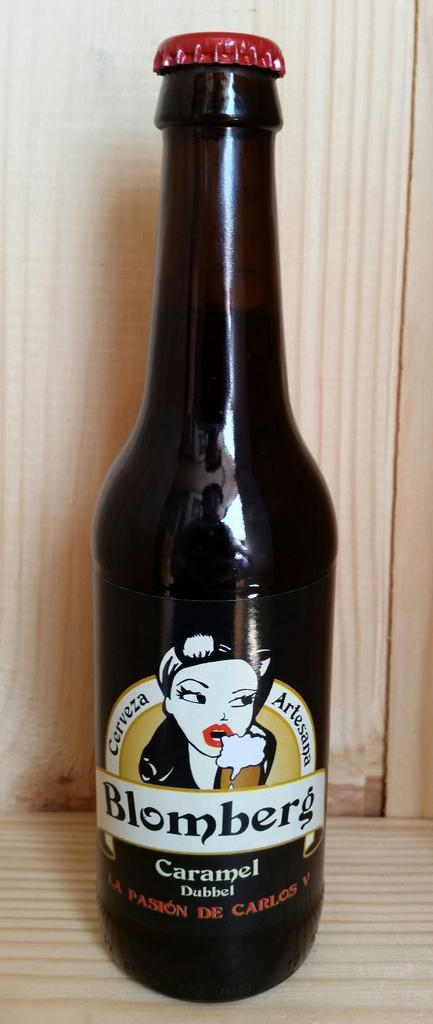<image>
Offer a succinct explanation of the picture presented. a bottle of Blomberg beer on the table 